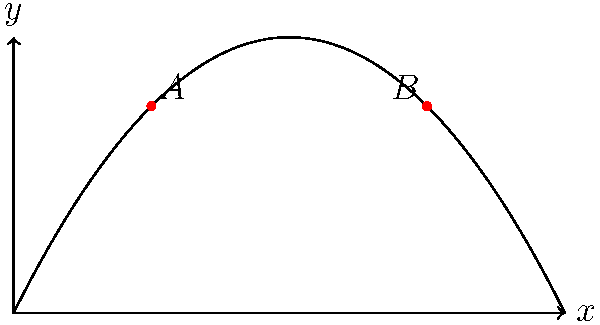At your son's basketball practice, you observe a shot that follows the trajectory shown in the graph. The path of the ball is described by the function $y = -5x^2 + 10x$, where $x$ and $y$ are measured in feet. If the ball travels from point A to point B in 1 second, what is the magnitude of the average velocity vector between these two points? Let's approach this step-by-step:

1) First, we need to find the coordinates of points A and B.
   - Point A occurs at $x = 2.5$ (half of 5, since it takes 1 second to go from A to B)
   - Point B occurs at $x = 7.5$ (2.5 + 5)

2) Calculate y-coordinates:
   - For A: $y_A = -5(2.5)^2 + 10(2.5) = -31.25 + 25 = -6.25$
   - For B: $y_B = -5(7.5)^2 + 10(7.5) = -281.25 + 75 = -206.25$

3) So, A(2.5, -6.25) and B(7.5, -206.25)

4) The displacement vector from A to B is:
   $\vec{AB} = (7.5 - 2.5, -206.25 - (-6.25)) = (5, -200)$

5) The average velocity vector is the displacement vector divided by time:
   $\vec{v}_{avg} = \frac{\vec{AB}}{t} = \frac{(5, -200)}{1} = (5, -200)$ ft/s

6) The magnitude of this vector is:
   $|\vec{v}_{avg}| = \sqrt{5^2 + (-200)^2} = \sqrt{25 + 40000} = \sqrt{40025} \approx 200.06$ ft/s

Therefore, the magnitude of the average velocity vector is approximately 200.06 ft/s.
Answer: 200.06 ft/s 